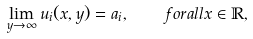Convert formula to latex. <formula><loc_0><loc_0><loc_500><loc_500>\lim _ { y \to \infty } u _ { i } ( x , y ) = a _ { i } , \quad f o r a l l x \in \mathbb { R } ,</formula> 